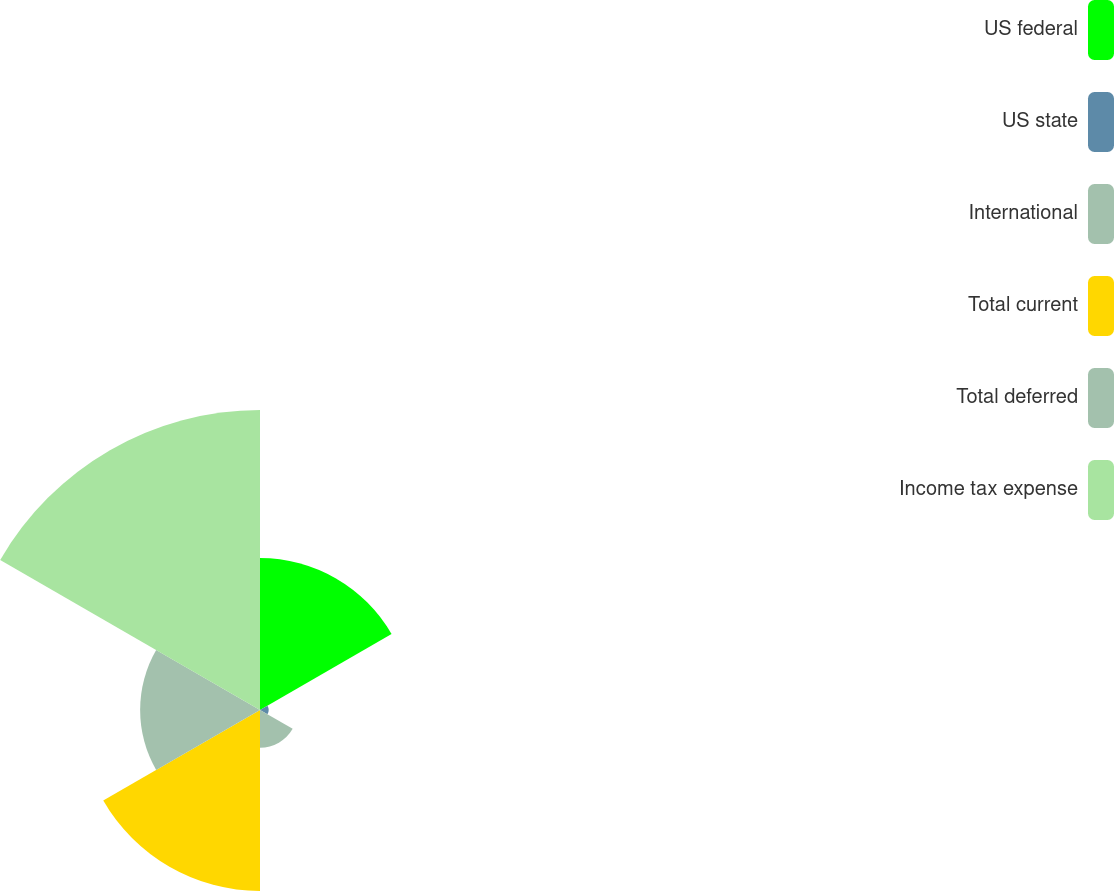Convert chart to OTSL. <chart><loc_0><loc_0><loc_500><loc_500><pie_chart><fcel>US federal<fcel>US state<fcel>International<fcel>Total current<fcel>Total deferred<fcel>Income tax expense<nl><fcel>19.01%<fcel>1.08%<fcel>4.72%<fcel>22.65%<fcel>15.0%<fcel>37.54%<nl></chart> 